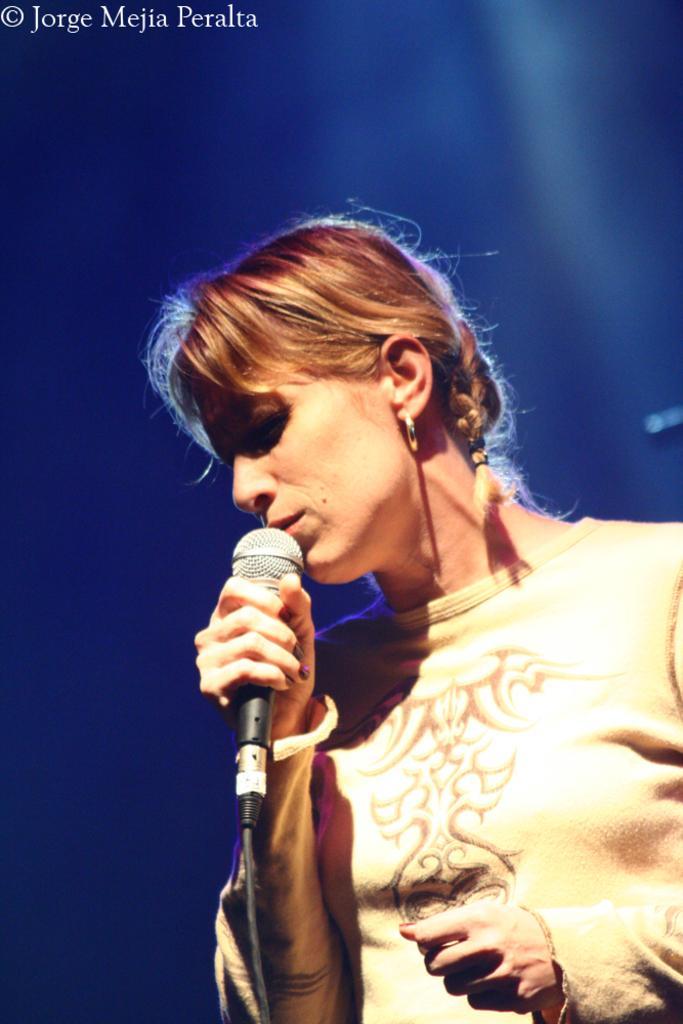How would you summarize this image in a sentence or two? On the right side of the image a lady is standing and holding a mic. 